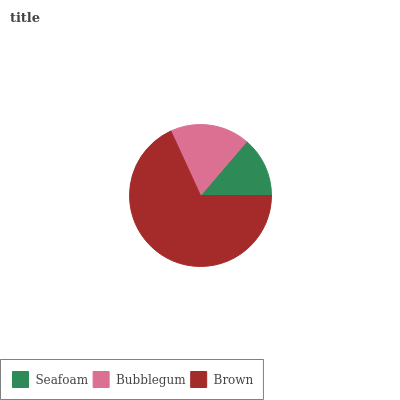Is Seafoam the minimum?
Answer yes or no. Yes. Is Brown the maximum?
Answer yes or no. Yes. Is Bubblegum the minimum?
Answer yes or no. No. Is Bubblegum the maximum?
Answer yes or no. No. Is Bubblegum greater than Seafoam?
Answer yes or no. Yes. Is Seafoam less than Bubblegum?
Answer yes or no. Yes. Is Seafoam greater than Bubblegum?
Answer yes or no. No. Is Bubblegum less than Seafoam?
Answer yes or no. No. Is Bubblegum the high median?
Answer yes or no. Yes. Is Bubblegum the low median?
Answer yes or no. Yes. Is Seafoam the high median?
Answer yes or no. No. Is Seafoam the low median?
Answer yes or no. No. 